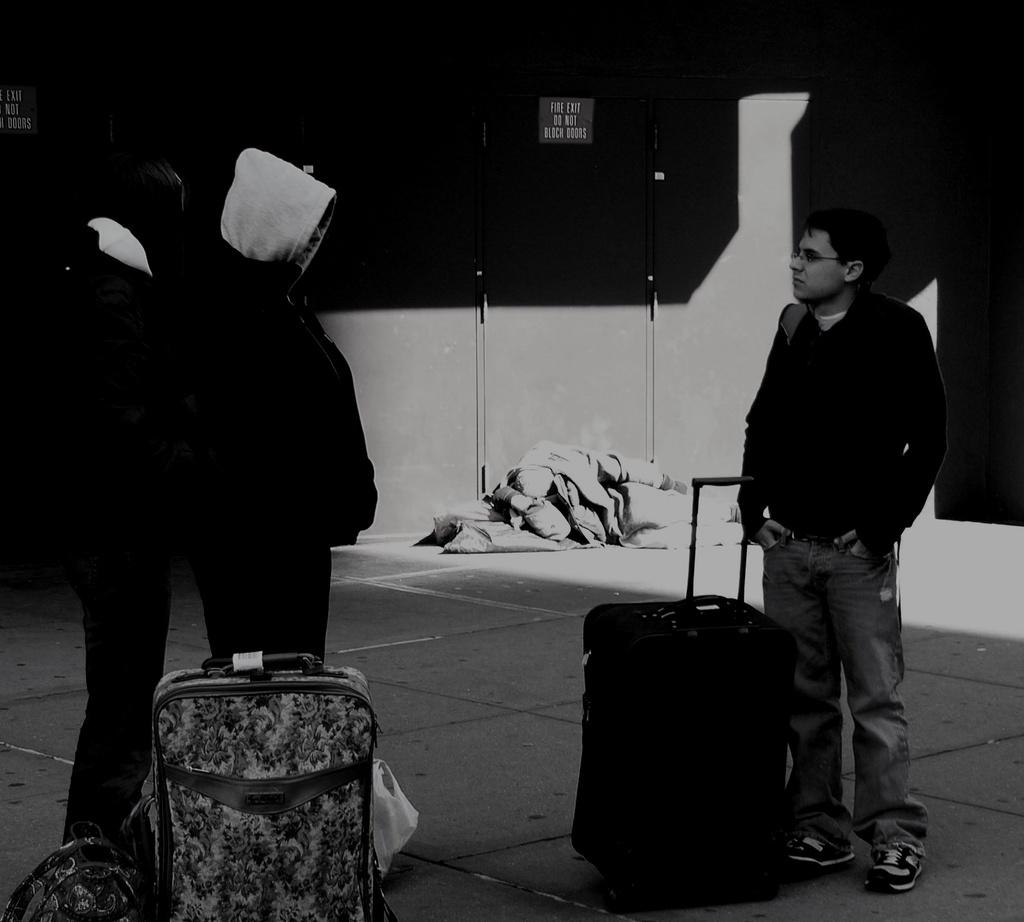How many people are present in the image? There are three people standing in the image. What is on the floor near the people? There are bags on the floor in the image. What can be seen in the background of the image? There is a wall and name boards in the background of the image. What else is visible in the background of the image? Clothes are visible in the background of the image. Can you see a quarter on the floor in the image? There is no quarter visible on the floor in the image. Are there any deer present in the image? There are no deer present in the image. 